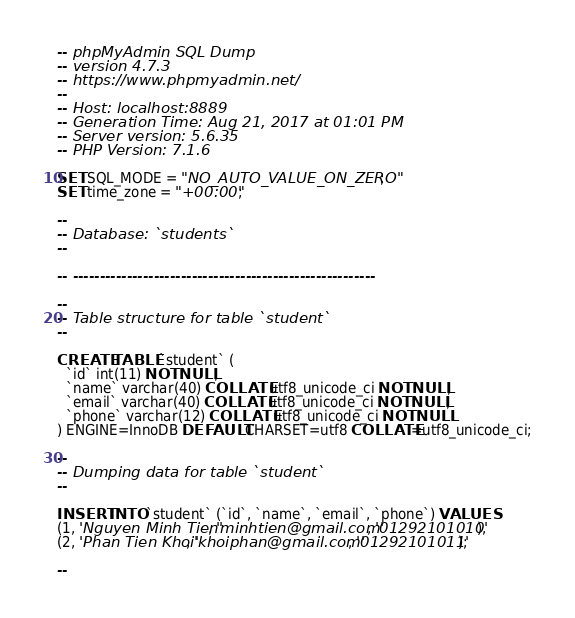Convert code to text. <code><loc_0><loc_0><loc_500><loc_500><_SQL_>-- phpMyAdmin SQL Dump
-- version 4.7.3
-- https://www.phpmyadmin.net/
--
-- Host: localhost:8889
-- Generation Time: Aug 21, 2017 at 01:01 PM
-- Server version: 5.6.35
-- PHP Version: 7.1.6

SET SQL_MODE = "NO_AUTO_VALUE_ON_ZERO";
SET time_zone = "+00:00";

--
-- Database: `students`
--

-- --------------------------------------------------------

--
-- Table structure for table `student`
--

CREATE TABLE `student` (
  `id` int(11) NOT NULL,
  `name` varchar(40) COLLATE utf8_unicode_ci NOT NULL,
  `email` varchar(40) COLLATE utf8_unicode_ci NOT NULL,
  `phone` varchar(12) COLLATE utf8_unicode_ci NOT NULL
) ENGINE=InnoDB DEFAULT CHARSET=utf8 COLLATE=utf8_unicode_ci;

--
-- Dumping data for table `student`
--

INSERT INTO `student` (`id`, `name`, `email`, `phone`) VALUES
(1, 'Nguyen Minh Tien', 'minhtien@gmail.com', '01292101010'),
(2, 'Phan Tien Khoi', 'khoiphan@gmail.com', '01292101011');

--</code> 